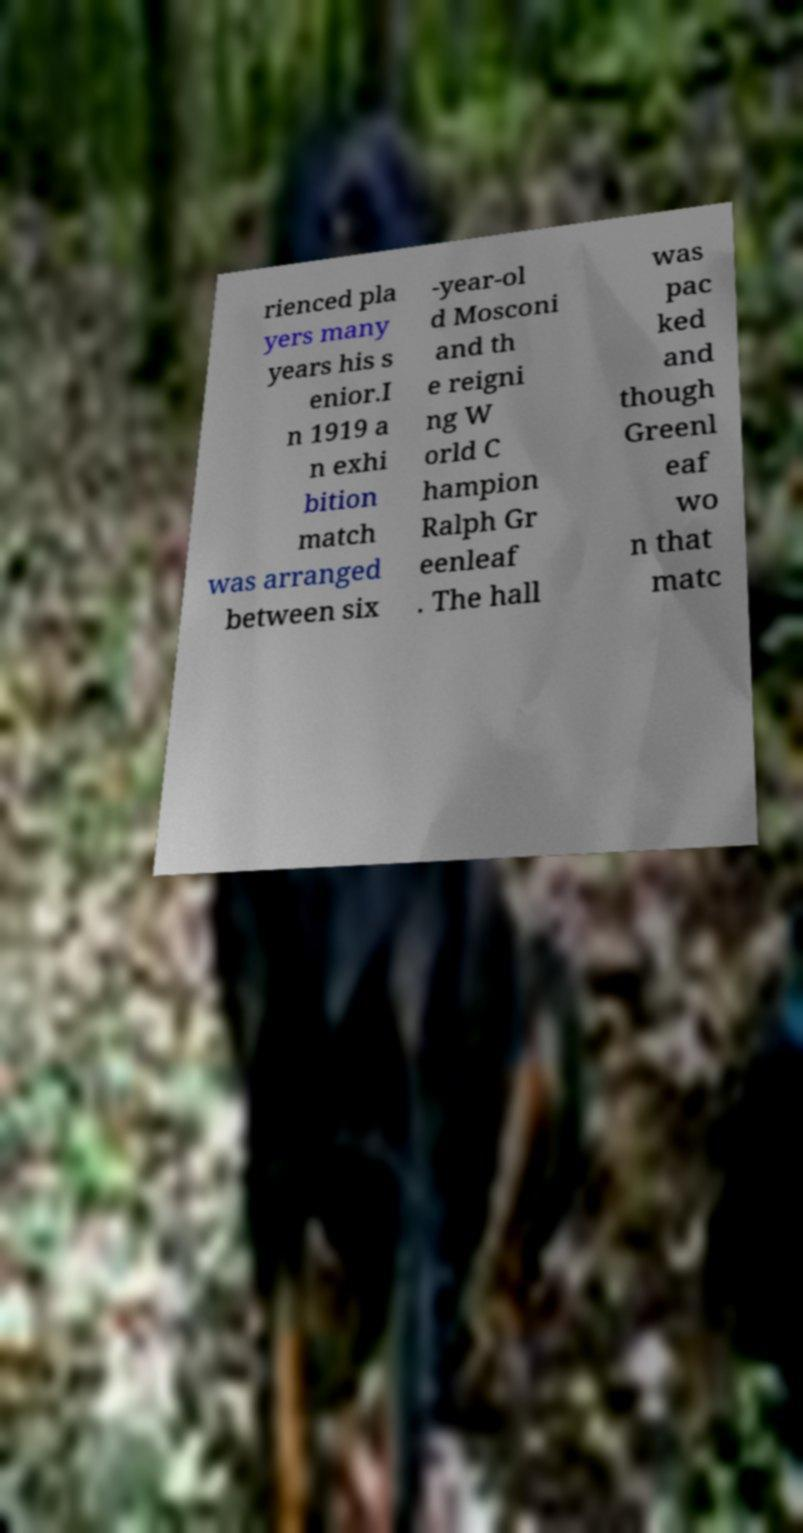For documentation purposes, I need the text within this image transcribed. Could you provide that? rienced pla yers many years his s enior.I n 1919 a n exhi bition match was arranged between six -year-ol d Mosconi and th e reigni ng W orld C hampion Ralph Gr eenleaf . The hall was pac ked and though Greenl eaf wo n that matc 